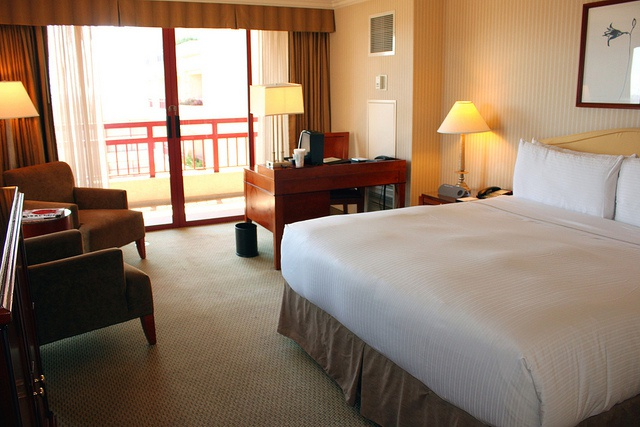Describe the objects in this image and their specific colors. I can see bed in maroon, darkgray, gray, and lightgray tones, chair in maroon, black, and gray tones, couch in maroon, black, and gray tones, couch in maroon, black, and brown tones, and chair in maroon, black, and brown tones in this image. 